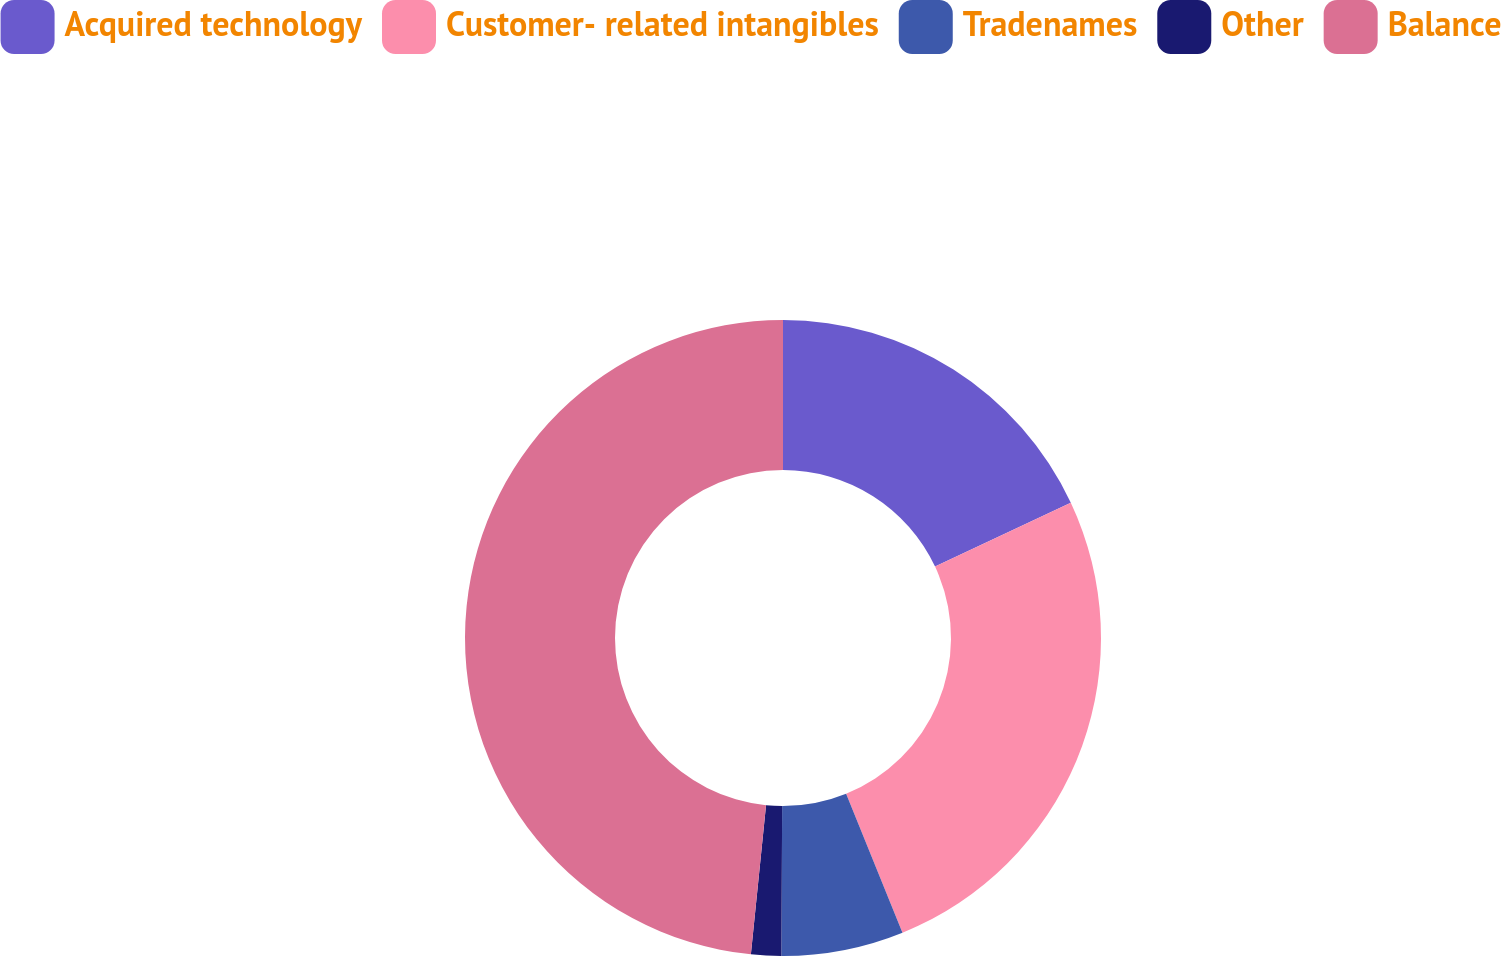Convert chart to OTSL. <chart><loc_0><loc_0><loc_500><loc_500><pie_chart><fcel>Acquired technology<fcel>Customer- related intangibles<fcel>Tradenames<fcel>Other<fcel>Balance<nl><fcel>18.01%<fcel>25.86%<fcel>6.21%<fcel>1.53%<fcel>48.39%<nl></chart> 